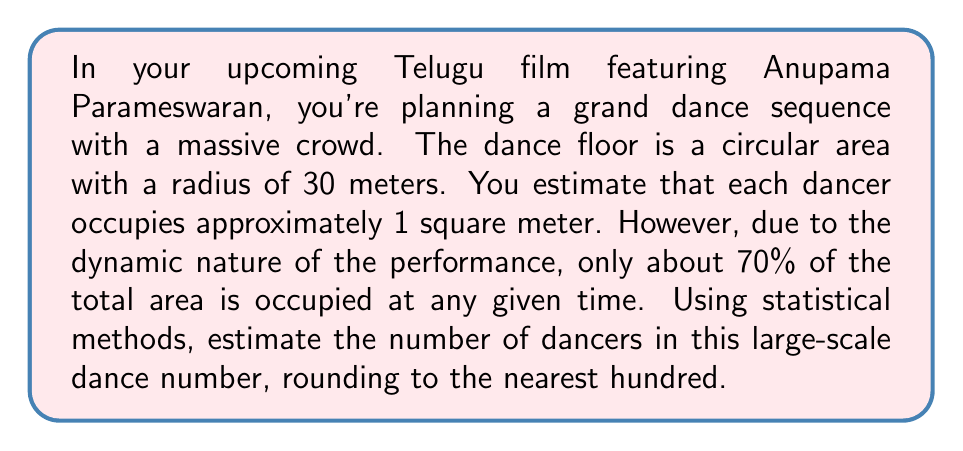Solve this math problem. Let's approach this problem step-by-step:

1. Calculate the total area of the circular dance floor:
   The area of a circle is given by $A = \pi r^2$
   $$A = \pi \cdot (30\text{ m})^2 = 900\pi \text{ m}^2$$

2. Convert the total area to square meters:
   $$A \approx 2827.43 \text{ m}^2$$

3. Calculate the usable area (70% of total area):
   $$A_{usable} = 0.7 \cdot 2827.43 \text{ m}^2 \approx 1979.20 \text{ m}^2$$

4. Estimate the number of dancers:
   Given that each dancer occupies approximately 1 square meter, the number of dancers can be estimated as:
   $$\text{Number of dancers} \approx 1979.20$$

5. Round to the nearest hundred:
   $$\text{Number of dancers} \approx 2000$$

This statistical method provides a reasonable estimate for the crowd size in your large-scale dance number, taking into account the circular dance floor and the dynamic nature of the performance.
Answer: 2000 dancers 